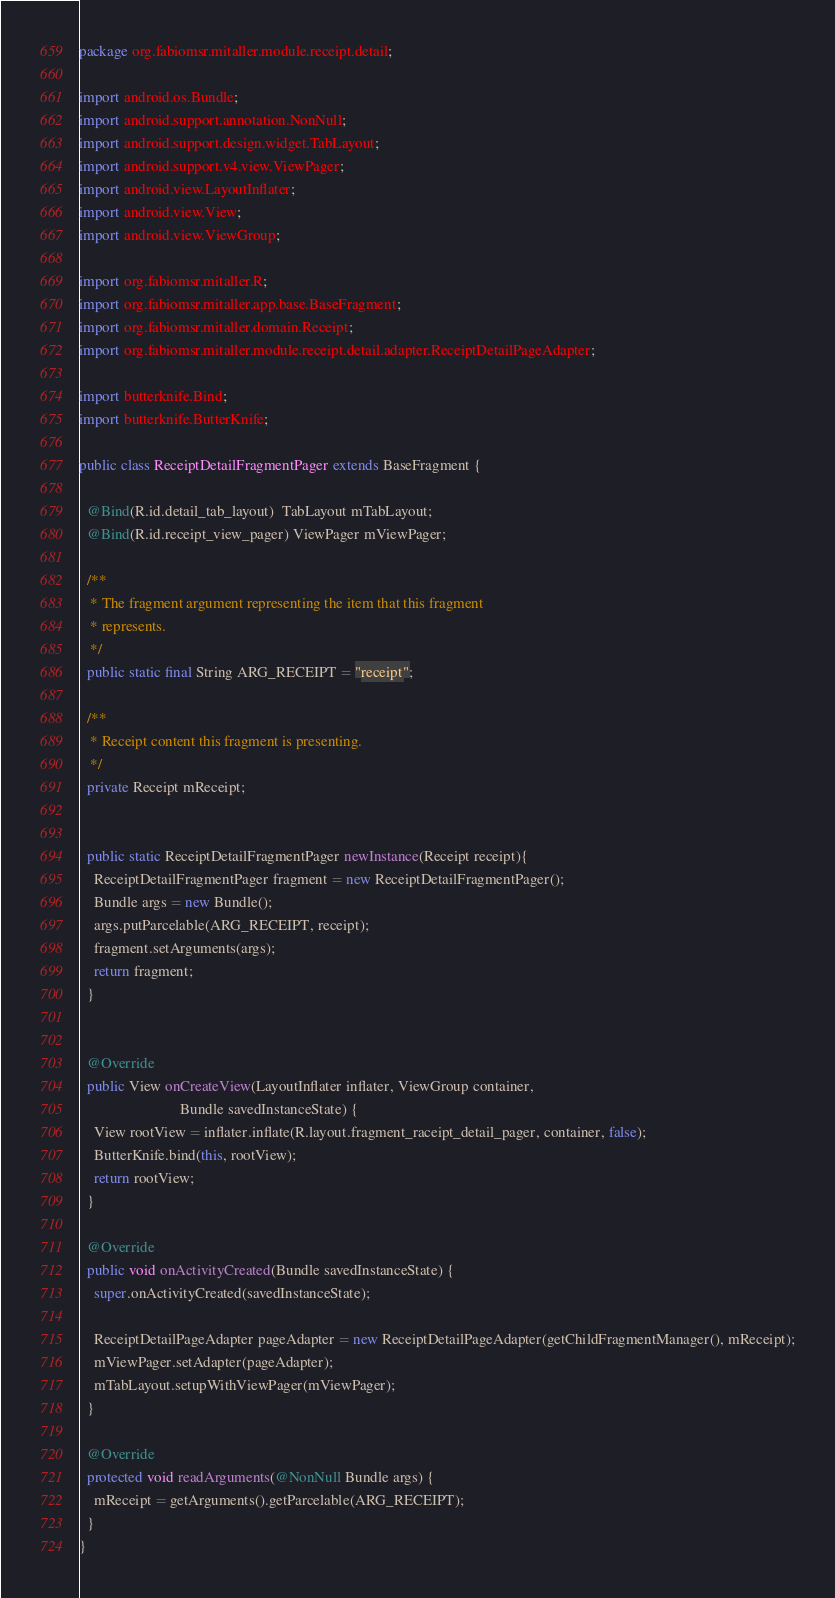<code> <loc_0><loc_0><loc_500><loc_500><_Java_>package org.fabiomsr.mitaller.module.receipt.detail;

import android.os.Bundle;
import android.support.annotation.NonNull;
import android.support.design.widget.TabLayout;
import android.support.v4.view.ViewPager;
import android.view.LayoutInflater;
import android.view.View;
import android.view.ViewGroup;

import org.fabiomsr.mitaller.R;
import org.fabiomsr.mitaller.app.base.BaseFragment;
import org.fabiomsr.mitaller.domain.Receipt;
import org.fabiomsr.mitaller.module.receipt.detail.adapter.ReceiptDetailPageAdapter;

import butterknife.Bind;
import butterknife.ButterKnife;

public class ReceiptDetailFragmentPager extends BaseFragment {

  @Bind(R.id.detail_tab_layout)  TabLayout mTabLayout;
  @Bind(R.id.receipt_view_pager) ViewPager mViewPager;

  /**
   * The fragment argument representing the item that this fragment
   * represents.
   */
  public static final String ARG_RECEIPT = "receipt";

  /**
   * Receipt content this fragment is presenting.
   */
  private Receipt mReceipt;


  public static ReceiptDetailFragmentPager newInstance(Receipt receipt){
    ReceiptDetailFragmentPager fragment = new ReceiptDetailFragmentPager();
    Bundle args = new Bundle();
    args.putParcelable(ARG_RECEIPT, receipt);
    fragment.setArguments(args);
    return fragment;
  }


  @Override
  public View onCreateView(LayoutInflater inflater, ViewGroup container,
                           Bundle savedInstanceState) {
    View rootView = inflater.inflate(R.layout.fragment_raceipt_detail_pager, container, false);
    ButterKnife.bind(this, rootView);
    return rootView;
  }

  @Override
  public void onActivityCreated(Bundle savedInstanceState) {
    super.onActivityCreated(savedInstanceState);

    ReceiptDetailPageAdapter pageAdapter = new ReceiptDetailPageAdapter(getChildFragmentManager(), mReceipt);
    mViewPager.setAdapter(pageAdapter);
    mTabLayout.setupWithViewPager(mViewPager);
  }

  @Override
  protected void readArguments(@NonNull Bundle args) {
    mReceipt = getArguments().getParcelable(ARG_RECEIPT);
  }
}
</code> 